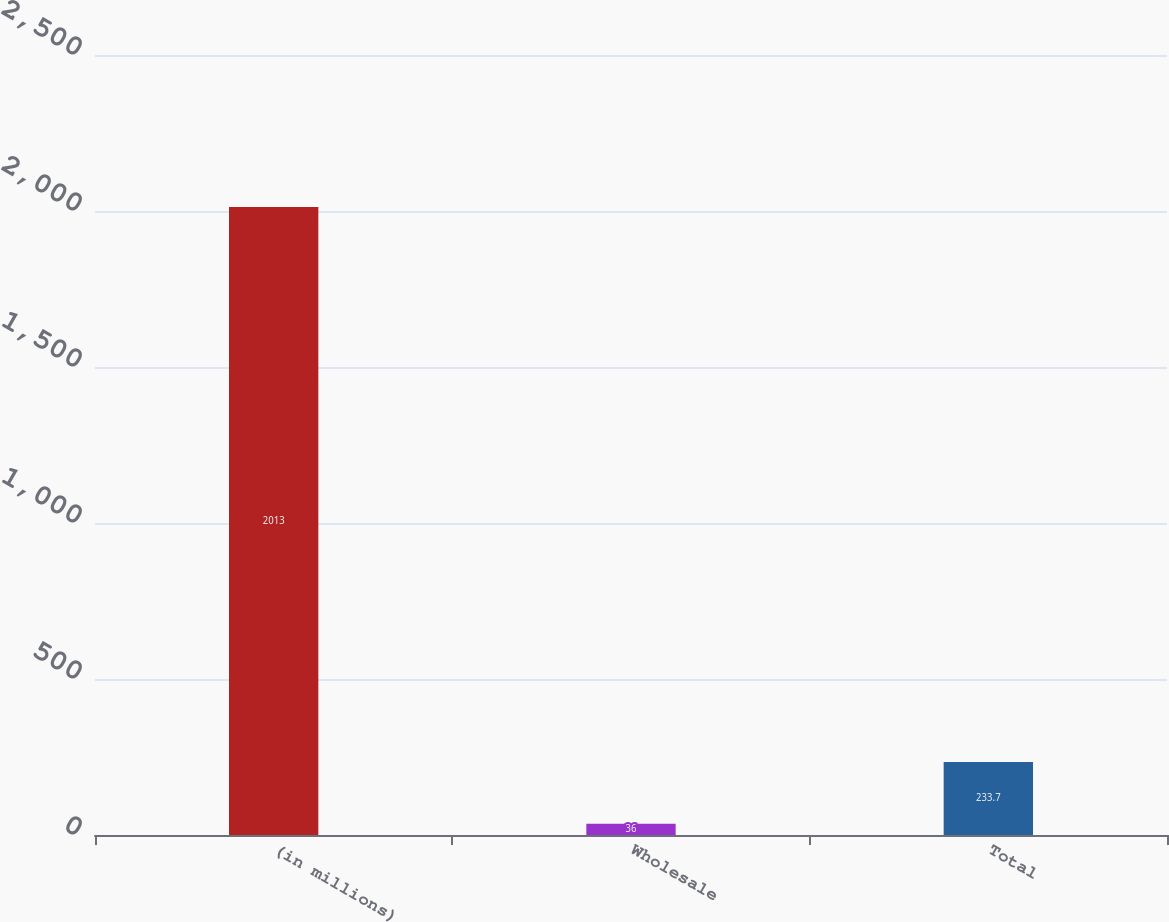Convert chart. <chart><loc_0><loc_0><loc_500><loc_500><bar_chart><fcel>(in millions)<fcel>Wholesale<fcel>Total<nl><fcel>2013<fcel>36<fcel>233.7<nl></chart> 